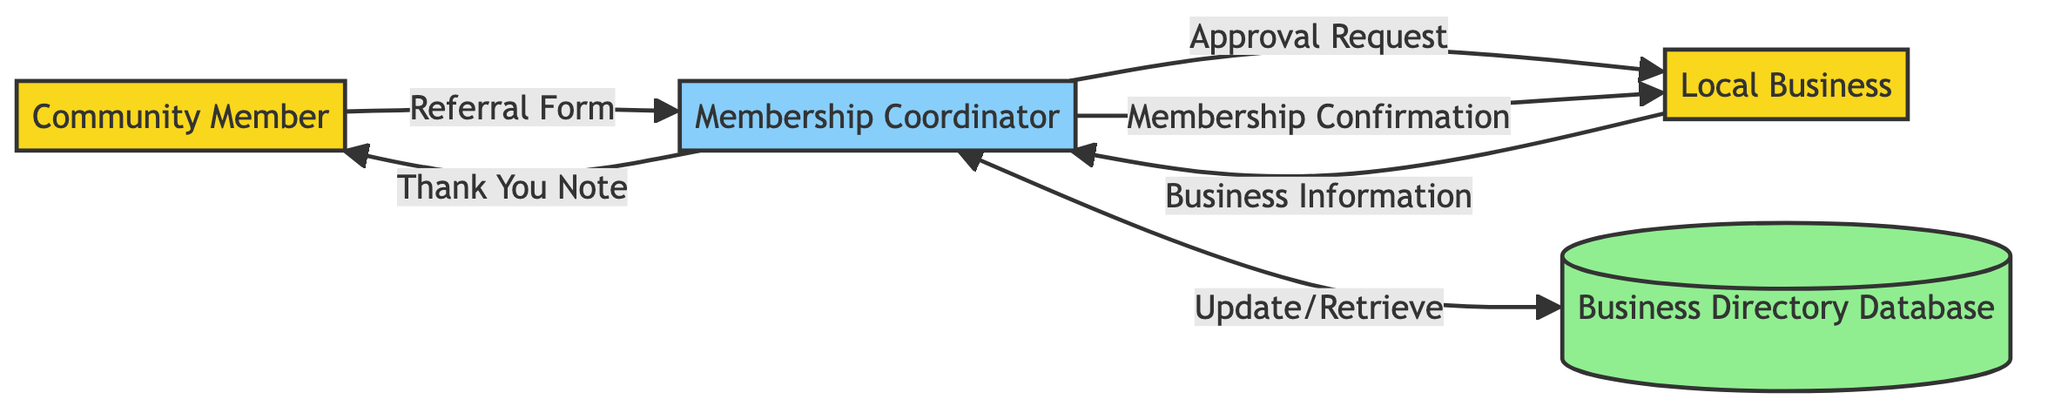What is the role of the Community Member in the process? The Community Member is an external entity who initiates the membership referral process by filling out the Referral Form.
Answer: Volunteer How many external entities are present in the diagram? The diagram contains two external entities: Community Member and Local Business.
Answer: 2 What data flow does the Membership Coordinator send to the Local Business after approval? After the approval process, the Membership Coordinator sends the Membership Confirmation to the Local Business to notify them of their membership status.
Answer: Membership Confirmation Which data store does the Membership Coordinator interact with? The Membership Coordinator interacts with the Business Directory Database, where information on local businesses and their membership statuses is stored.
Answer: Business Directory Database What does the Membership Coordinator send to the Community Member to acknowledge the referral? The Membership Coordinator sends a Thank You Note to the Community Member as a form of acknowledgment for their referral.
Answer: Thank You Note How does the Membership Coordinator verify the referral? The Membership Coordinator sends an Approval Request to the Local Business to verify the referral and seek approval for membership.
Answer: Approval Request Describe the flow of information from the Community Member to the Local Business. The flow begins with the Community Member submitting the Referral Form to the Membership Coordinator, who then sends an Approval Request to the Local Business, leading the business to provide its Business Information.
Answer: Referral Form, Approval Request, Business Information What type of diagram is being used to represent the Membership Referral Process? The diagram represents the Membership Referral Process using a Data Flow Diagram, which visually depicts the flow of data between entities and processes.
Answer: Data Flow Diagram 